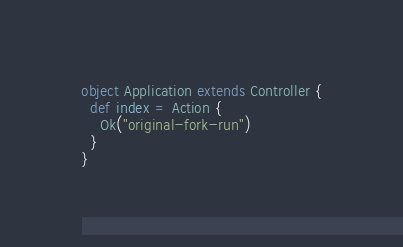Convert code to text. <code><loc_0><loc_0><loc_500><loc_500><_Scala_>object Application extends Controller {
  def index = Action {
    Ok("original-fork-run")
  }
}
</code> 